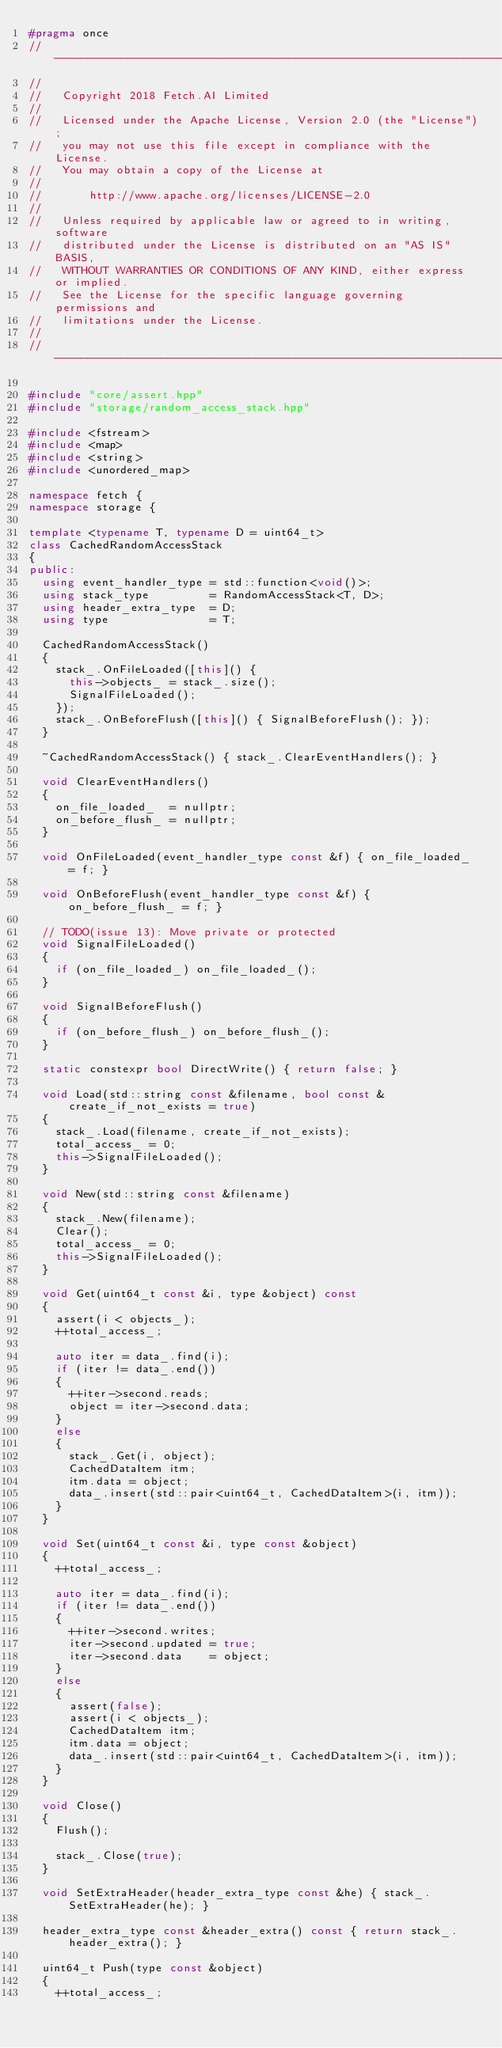<code> <loc_0><loc_0><loc_500><loc_500><_C++_>#pragma once
//------------------------------------------------------------------------------
//
//   Copyright 2018 Fetch.AI Limited
//
//   Licensed under the Apache License, Version 2.0 (the "License");
//   you may not use this file except in compliance with the License.
//   You may obtain a copy of the License at
//
//       http://www.apache.org/licenses/LICENSE-2.0
//
//   Unless required by applicable law or agreed to in writing, software
//   distributed under the License is distributed on an "AS IS" BASIS,
//   WITHOUT WARRANTIES OR CONDITIONS OF ANY KIND, either express or implied.
//   See the License for the specific language governing permissions and
//   limitations under the License.
//
//------------------------------------------------------------------------------

#include "core/assert.hpp"
#include "storage/random_access_stack.hpp"

#include <fstream>
#include <map>
#include <string>
#include <unordered_map>

namespace fetch {
namespace storage {

template <typename T, typename D = uint64_t>
class CachedRandomAccessStack
{
public:
  using event_handler_type = std::function<void()>;
  using stack_type         = RandomAccessStack<T, D>;
  using header_extra_type  = D;
  using type               = T;

  CachedRandomAccessStack()
  {
    stack_.OnFileLoaded([this]() {
      this->objects_ = stack_.size();
      SignalFileLoaded();
    });
    stack_.OnBeforeFlush([this]() { SignalBeforeFlush(); });
  }

  ~CachedRandomAccessStack() { stack_.ClearEventHandlers(); }

  void ClearEventHandlers()
  {
    on_file_loaded_  = nullptr;
    on_before_flush_ = nullptr;
  }

  void OnFileLoaded(event_handler_type const &f) { on_file_loaded_ = f; }

  void OnBeforeFlush(event_handler_type const &f) { on_before_flush_ = f; }

  // TODO(issue 13): Move private or protected
  void SignalFileLoaded()
  {
    if (on_file_loaded_) on_file_loaded_();
  }

  void SignalBeforeFlush()
  {
    if (on_before_flush_) on_before_flush_();
  }

  static constexpr bool DirectWrite() { return false; }

  void Load(std::string const &filename, bool const &create_if_not_exists = true)
  {
    stack_.Load(filename, create_if_not_exists);
    total_access_ = 0;
    this->SignalFileLoaded();
  }

  void New(std::string const &filename)
  {
    stack_.New(filename);
    Clear();
    total_access_ = 0;
    this->SignalFileLoaded();
  }

  void Get(uint64_t const &i, type &object) const
  {
    assert(i < objects_);
    ++total_access_;

    auto iter = data_.find(i);
    if (iter != data_.end())
    {
      ++iter->second.reads;
      object = iter->second.data;
    }
    else
    {
      stack_.Get(i, object);
      CachedDataItem itm;
      itm.data = object;
      data_.insert(std::pair<uint64_t, CachedDataItem>(i, itm));
    }
  }

  void Set(uint64_t const &i, type const &object)
  {
    ++total_access_;

    auto iter = data_.find(i);
    if (iter != data_.end())
    {
      ++iter->second.writes;
      iter->second.updated = true;
      iter->second.data    = object;
    }
    else
    {
      assert(false);
      assert(i < objects_);
      CachedDataItem itm;
      itm.data = object;
      data_.insert(std::pair<uint64_t, CachedDataItem>(i, itm));
    }
  }

  void Close()
  {
    Flush();

    stack_.Close(true);
  }

  void SetExtraHeader(header_extra_type const &he) { stack_.SetExtraHeader(he); }

  header_extra_type const &header_extra() const { return stack_.header_extra(); }

  uint64_t Push(type const &object)
  {
    ++total_access_;</code> 